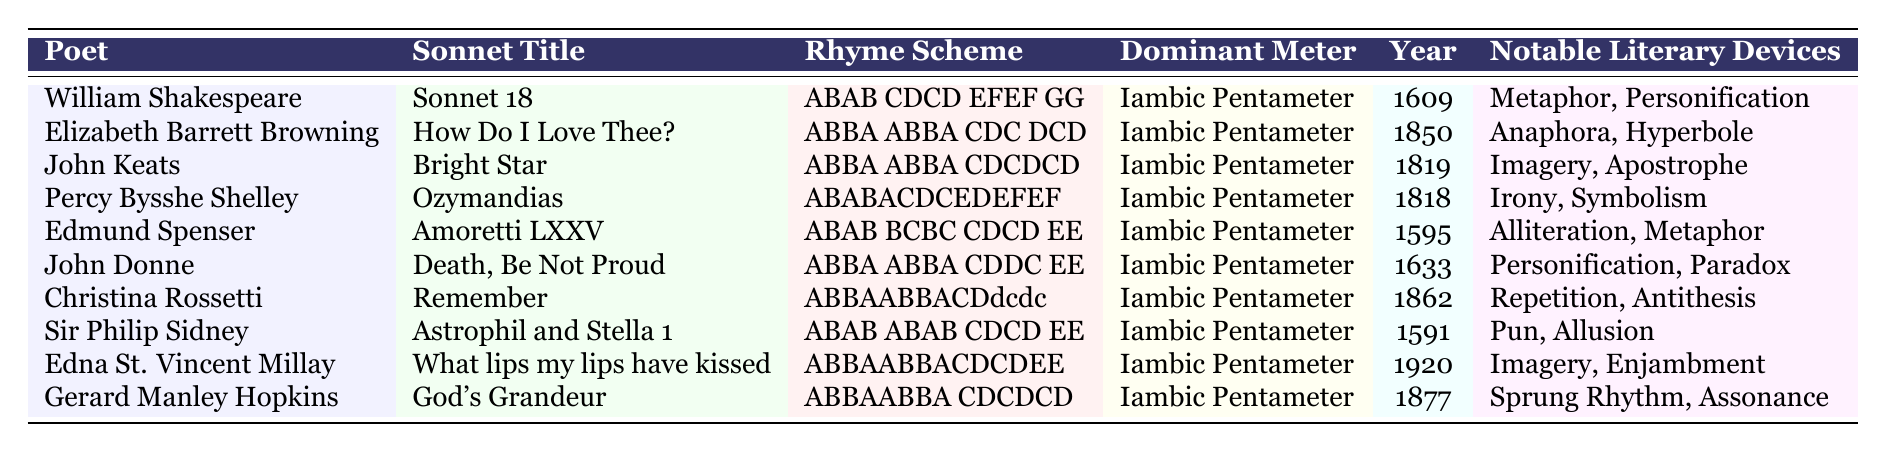What is the rhyme scheme of "Sonnet 18"? The table shows that the rhyme scheme for "Sonnet 18" by William Shakespeare is ABAB CDCD EFEF GG.
Answer: ABAB CDCD EFEF GG Who published "How Do I Love Thee?" and in what year? The table lists Elizabeth Barrett Browning as the author of "How Do I Love Thee?" and it was published in the year 1850.
Answer: Elizabeth Barrett Browning, 1850 Which sonnets have a rhyme scheme beginning with ABBA? By reviewing the table, the sonnets with a rhyme scheme starting with ABBA are "How Do I Love Thee?" by Elizabeth Barrett Browning, "Bright Star" by John Keats, "Death, Be Not Proud" by John Donne, and "Remember" by Christina Rossetti.
Answer: Four sonnets What is the dominant meter for "Ozymandias"? According to the table, the dominant meter for "Ozymandias" by Percy Bysshe Shelley is Iambic Pentameter.
Answer: Iambic Pentameter Which poet is associated with the rhyme scheme ABABACDCEDEFEF? The table indicates that the poet associated with this rhyme scheme is Percy Bysshe Shelley for the sonnet "Ozymandias."
Answer: Percy Bysshe Shelley How many sonnets have notable literary devices that include "Imagery"? The table lists "Bright Star" by John Keats, "What lips my lips have kissed" by Edna St. Vincent Millay, and "God's Grandeur" by Gerard Manley Hopkins as sonnets with Imagery as a notable literary device, totaling three.
Answer: Three sonnets Is there a sonnet that features the literary device "Repetition"? Yes, the table indicates that "Remember" by Christina Rossetti features the literary device "Repetition."
Answer: Yes What is the average year of publication for the sonnets listed? The sum of all publication years is 1609 + 1850 + 1819 + 1818 + 1595 + 1633 + 1862 + 1591 + 1920 + 1877 = 18199. There are 10 sonnets, so the average is 18199 / 10 = 1819.9, which we can round to 1820.
Answer: 1820 Which poet has the greatest number of notable literary devices listed? The table shows that both Elizabeth Barrett Browning and Christina Rossetti have notable literary devices with two terms each, namely "Anaphora, Hyperbole" and "Repetition, Antithesis," so they are tied for the most.
Answer: Elizabeth Barrett Browning and Christina Rossetti How does the rhyme scheme of "Astrophil and Stella 1" compare to "Sonnet 18"? Comparing the two, "Astrophil and Stella 1" has a rhyme scheme of ABAB ABAB CDCD EE, while "Sonnet 18" has ABAB CDCD EFEF GG. They both start with ABAB, but differ significantly thereafter.
Answer: Different rhyme schemes 